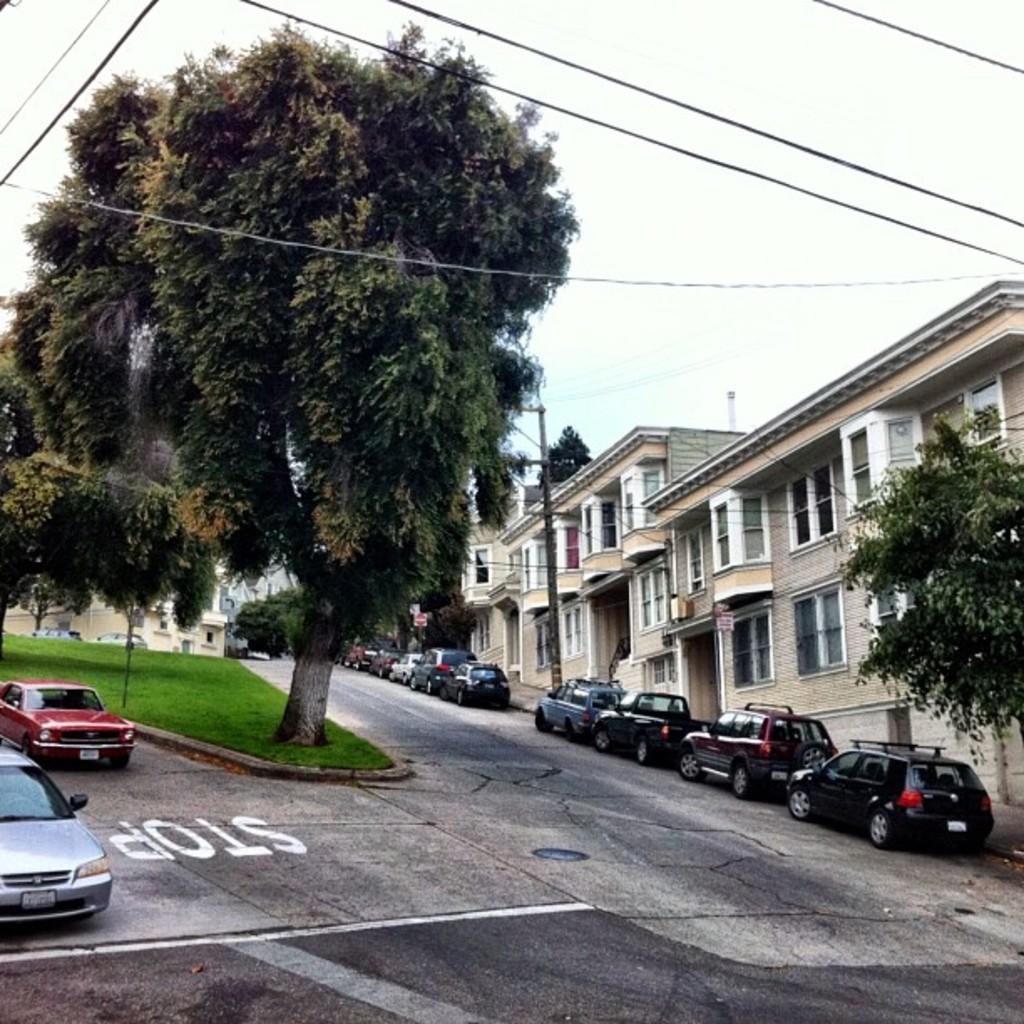Could you give a brief overview of what you see in this image? In this picture there are cars on the right and left side of the image, there is a tree on the left side of the image and there are trees, poles, and buildings in the image and there are wires at the top side of the image. 